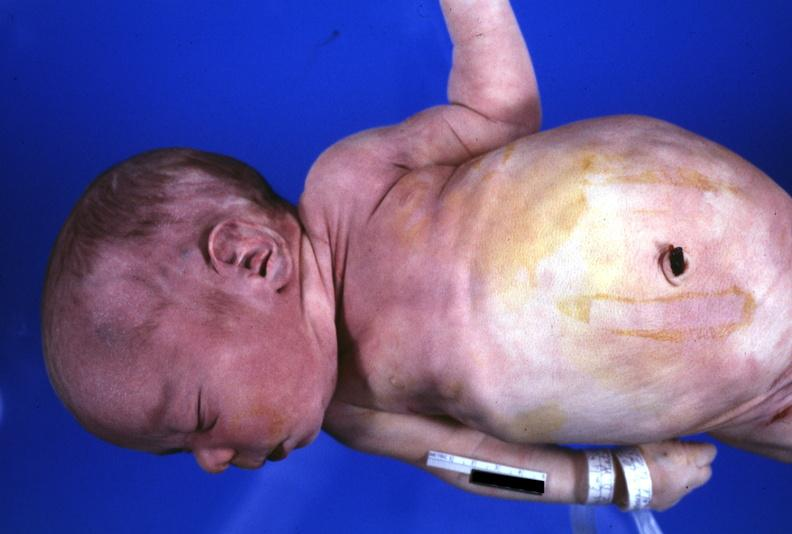what is present?
Answer the question using a single word or phrase. Potters facies 